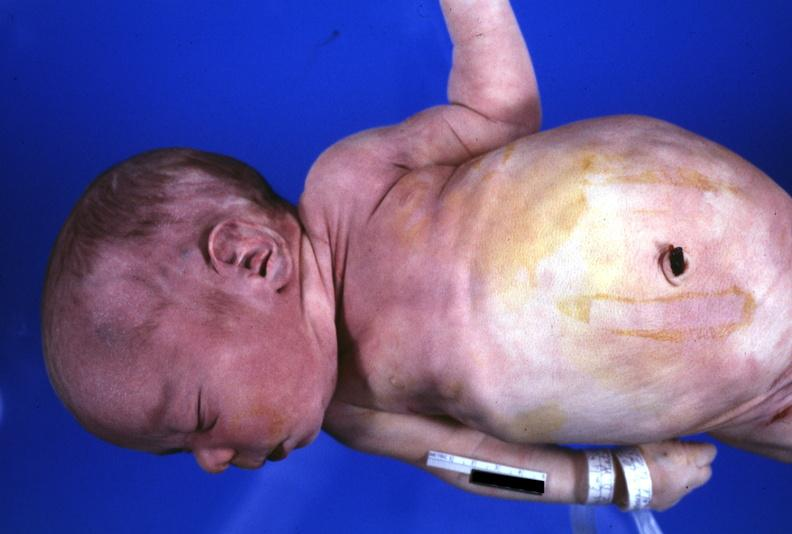what is present?
Answer the question using a single word or phrase. Potters facies 